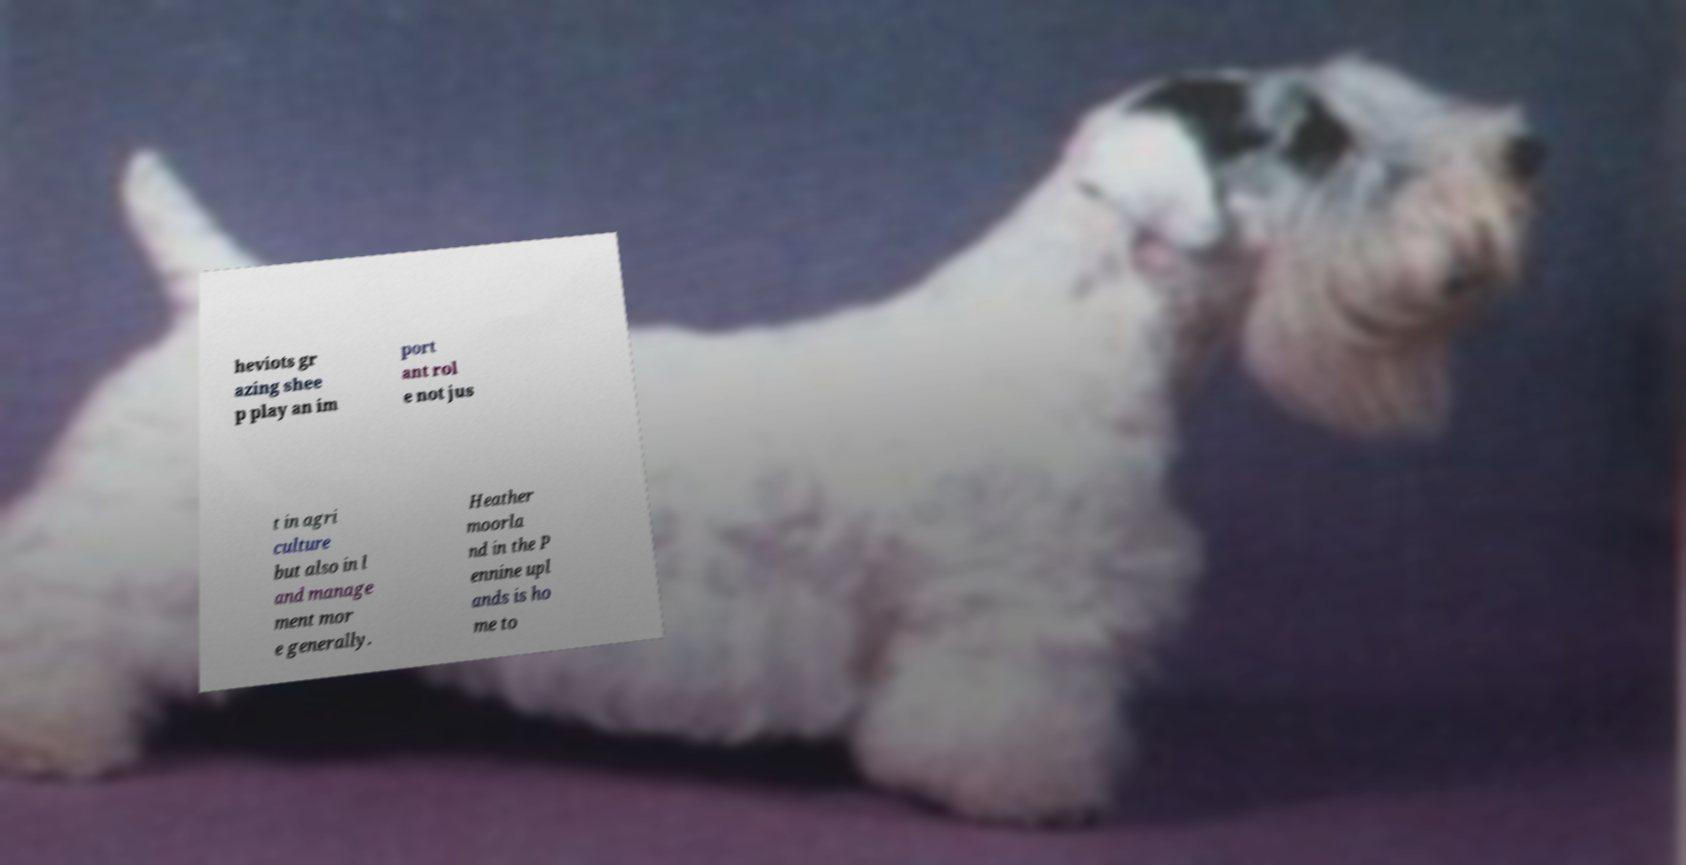Could you extract and type out the text from this image? heviots gr azing shee p play an im port ant rol e not jus t in agri culture but also in l and manage ment mor e generally. Heather moorla nd in the P ennine upl ands is ho me to 